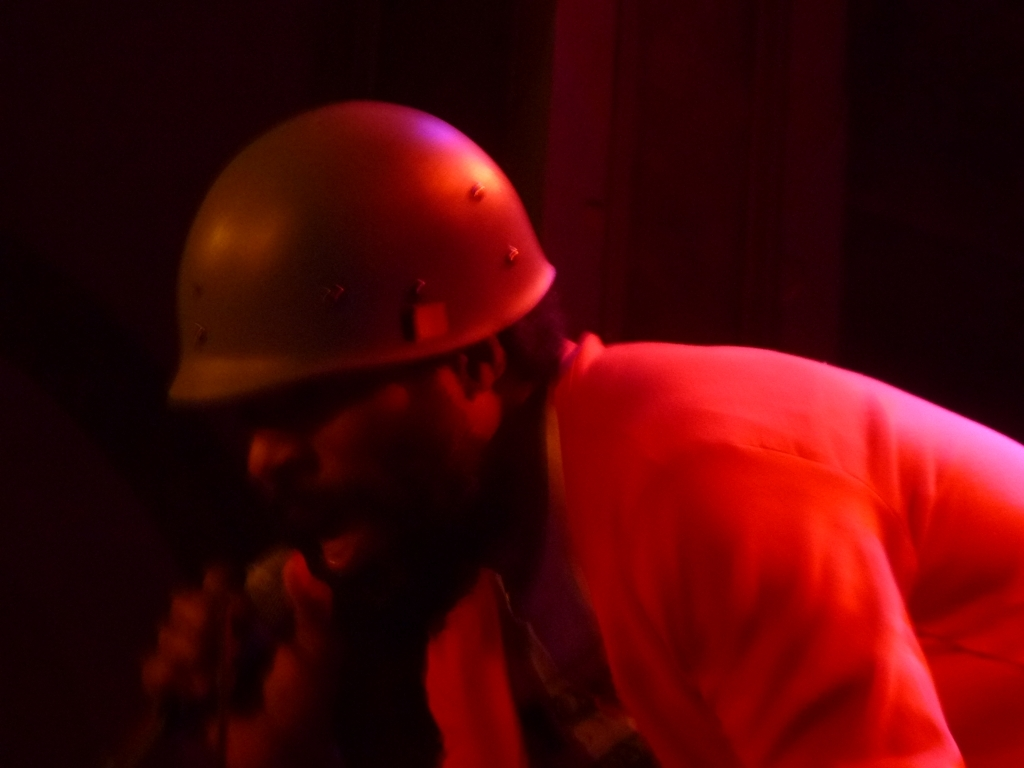Could you provide a potential narrative that this image might represent? Based on the image, one could imagine a narrative where the individual is a worker or an artist caught in a moment of deep concentration. Perhaps he is a craftsman working late into the night on a project, or an actor rehearsing for a role in a dimly lit environment, embodying the character's emotions through his expression and posture. 